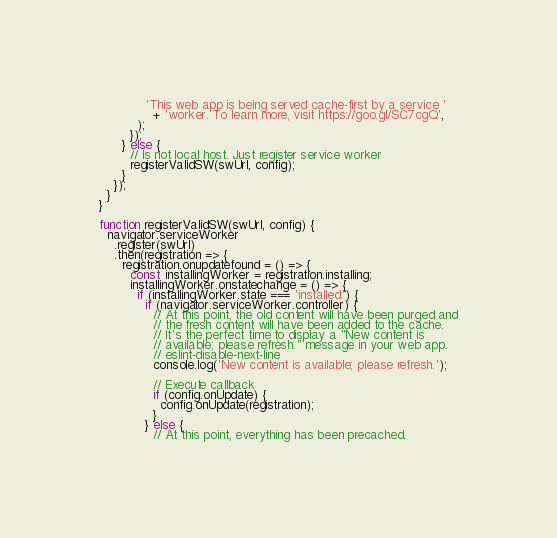Convert code to text. <code><loc_0><loc_0><loc_500><loc_500><_JavaScript_>            'This web app is being served cache-first by a service '
              + 'worker. To learn more, visit https://goo.gl/SC7cgQ',
          );
        });
      } else {
        // Is not local host. Just register service worker
        registerValidSW(swUrl, config);
      }
    });
  }
}

function registerValidSW(swUrl, config) {
  navigator.serviceWorker
    .register(swUrl)
    .then(registration => {
      registration.onupdatefound = () => {
        const installingWorker = registration.installing;
        installingWorker.onstatechange = () => {
          if (installingWorker.state === 'installed') {
            if (navigator.serviceWorker.controller) {
              // At this point, the old content will have been purged and
              // the fresh content will have been added to the cache.
              // It's the perfect time to display a "New content is
              // available; please refresh." message in your web app.
              // eslint-disable-next-line
              console.log('New content is available; please refresh.');

              // Execute callback
              if (config.onUpdate) {
                config.onUpdate(registration);
              }
            } else {
              // At this point, everything has been precached.</code> 